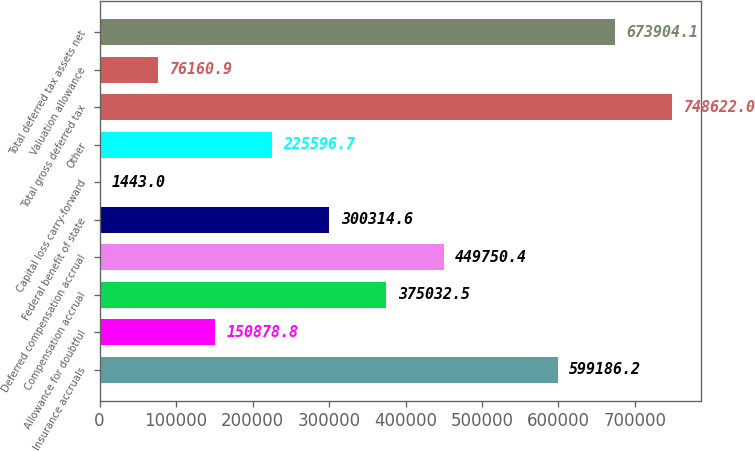<chart> <loc_0><loc_0><loc_500><loc_500><bar_chart><fcel>Insurance accruals<fcel>Allowance for doubtful<fcel>Compensation accrual<fcel>Deferred compensation accrual<fcel>Federal benefit of state<fcel>Capital loss carry-forward<fcel>Other<fcel>Total gross deferred tax<fcel>Valuation allowance<fcel>Total deferred tax assets net<nl><fcel>599186<fcel>150879<fcel>375032<fcel>449750<fcel>300315<fcel>1443<fcel>225597<fcel>748622<fcel>76160.9<fcel>673904<nl></chart> 